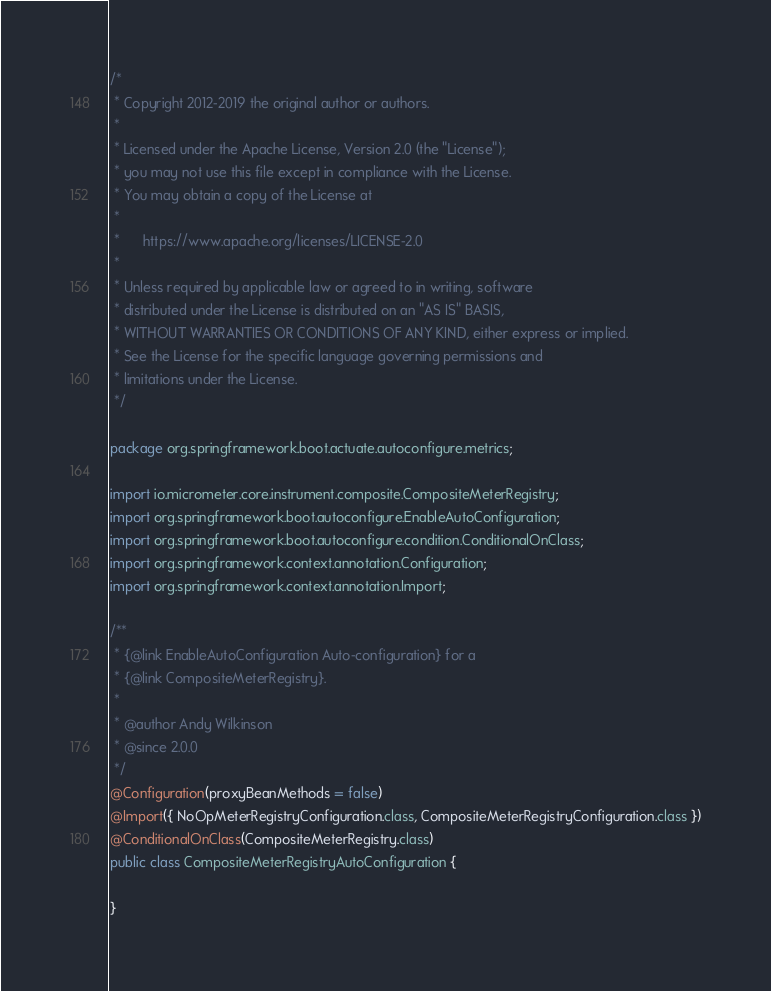Convert code to text. <code><loc_0><loc_0><loc_500><loc_500><_Java_>/*
 * Copyright 2012-2019 the original author or authors.
 *
 * Licensed under the Apache License, Version 2.0 (the "License");
 * you may not use this file except in compliance with the License.
 * You may obtain a copy of the License at
 *
 *      https://www.apache.org/licenses/LICENSE-2.0
 *
 * Unless required by applicable law or agreed to in writing, software
 * distributed under the License is distributed on an "AS IS" BASIS,
 * WITHOUT WARRANTIES OR CONDITIONS OF ANY KIND, either express or implied.
 * See the License for the specific language governing permissions and
 * limitations under the License.
 */

package org.springframework.boot.actuate.autoconfigure.metrics;

import io.micrometer.core.instrument.composite.CompositeMeterRegistry;
import org.springframework.boot.autoconfigure.EnableAutoConfiguration;
import org.springframework.boot.autoconfigure.condition.ConditionalOnClass;
import org.springframework.context.annotation.Configuration;
import org.springframework.context.annotation.Import;

/**
 * {@link EnableAutoConfiguration Auto-configuration} for a
 * {@link CompositeMeterRegistry}.
 *
 * @author Andy Wilkinson
 * @since 2.0.0
 */
@Configuration(proxyBeanMethods = false)
@Import({ NoOpMeterRegistryConfiguration.class, CompositeMeterRegistryConfiguration.class })
@ConditionalOnClass(CompositeMeterRegistry.class)
public class CompositeMeterRegistryAutoConfiguration {

}
</code> 